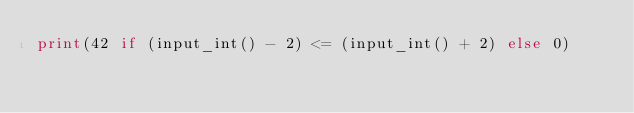Convert code to text. <code><loc_0><loc_0><loc_500><loc_500><_Python_>print(42 if (input_int() - 2) <= (input_int() + 2) else 0)
</code> 